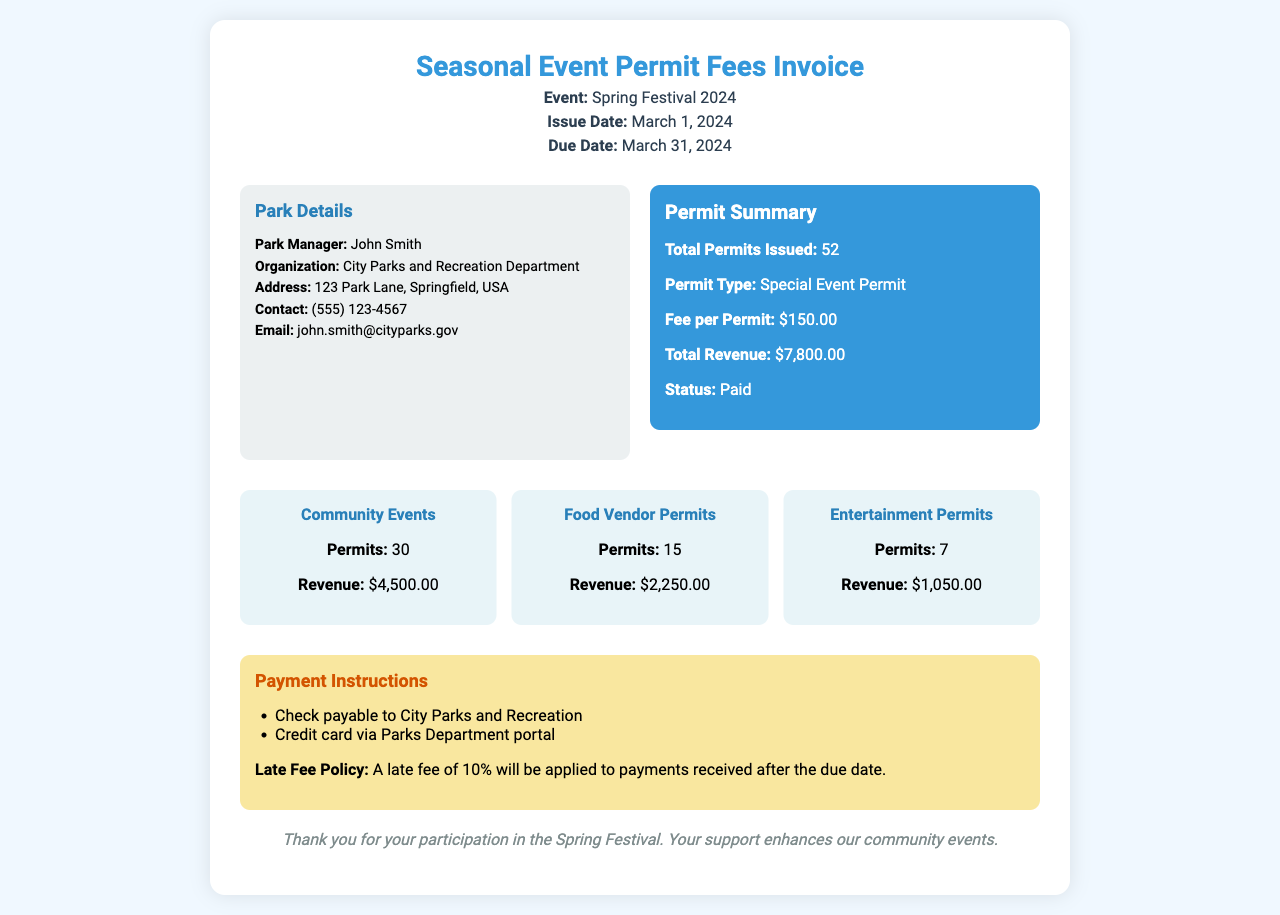what is the total revenue? The total revenue is stated in the document under the permit summary section, which lists it as $7,800.00.
Answer: $7,800.00 how many permits were issued? The total permits issued is directly provided in the permit summary section, which states 52.
Answer: 52 who is the park manager? The name of the park manager is provided in the park details section, which lists it as John Smith.
Answer: John Smith what is the fee per permit? The fee per permit is specified in the permit summary section as $150.00.
Answer: $150.00 what is the due date for payment? The due date for payment is indicated in the header of the document as March 31, 2024.
Answer: March 31, 2024 how many community event permits were issued? The breakdown section lists that 30 permits were issued for community events.
Answer: 30 what is the revenue from food vendor permits? The revenue generated from food vendor permits is stated in the breakdown section as $2,250.00.
Answer: $2,250.00 what is the late fee policy mentioned? The document states that a late fee of 10% will be applied to payments received after the due date.
Answer: 10% what organization is responsible for the permit? The organization responsible for the permit is stated in the park details as the City Parks and Recreation Department.
Answer: City Parks and Recreation Department 